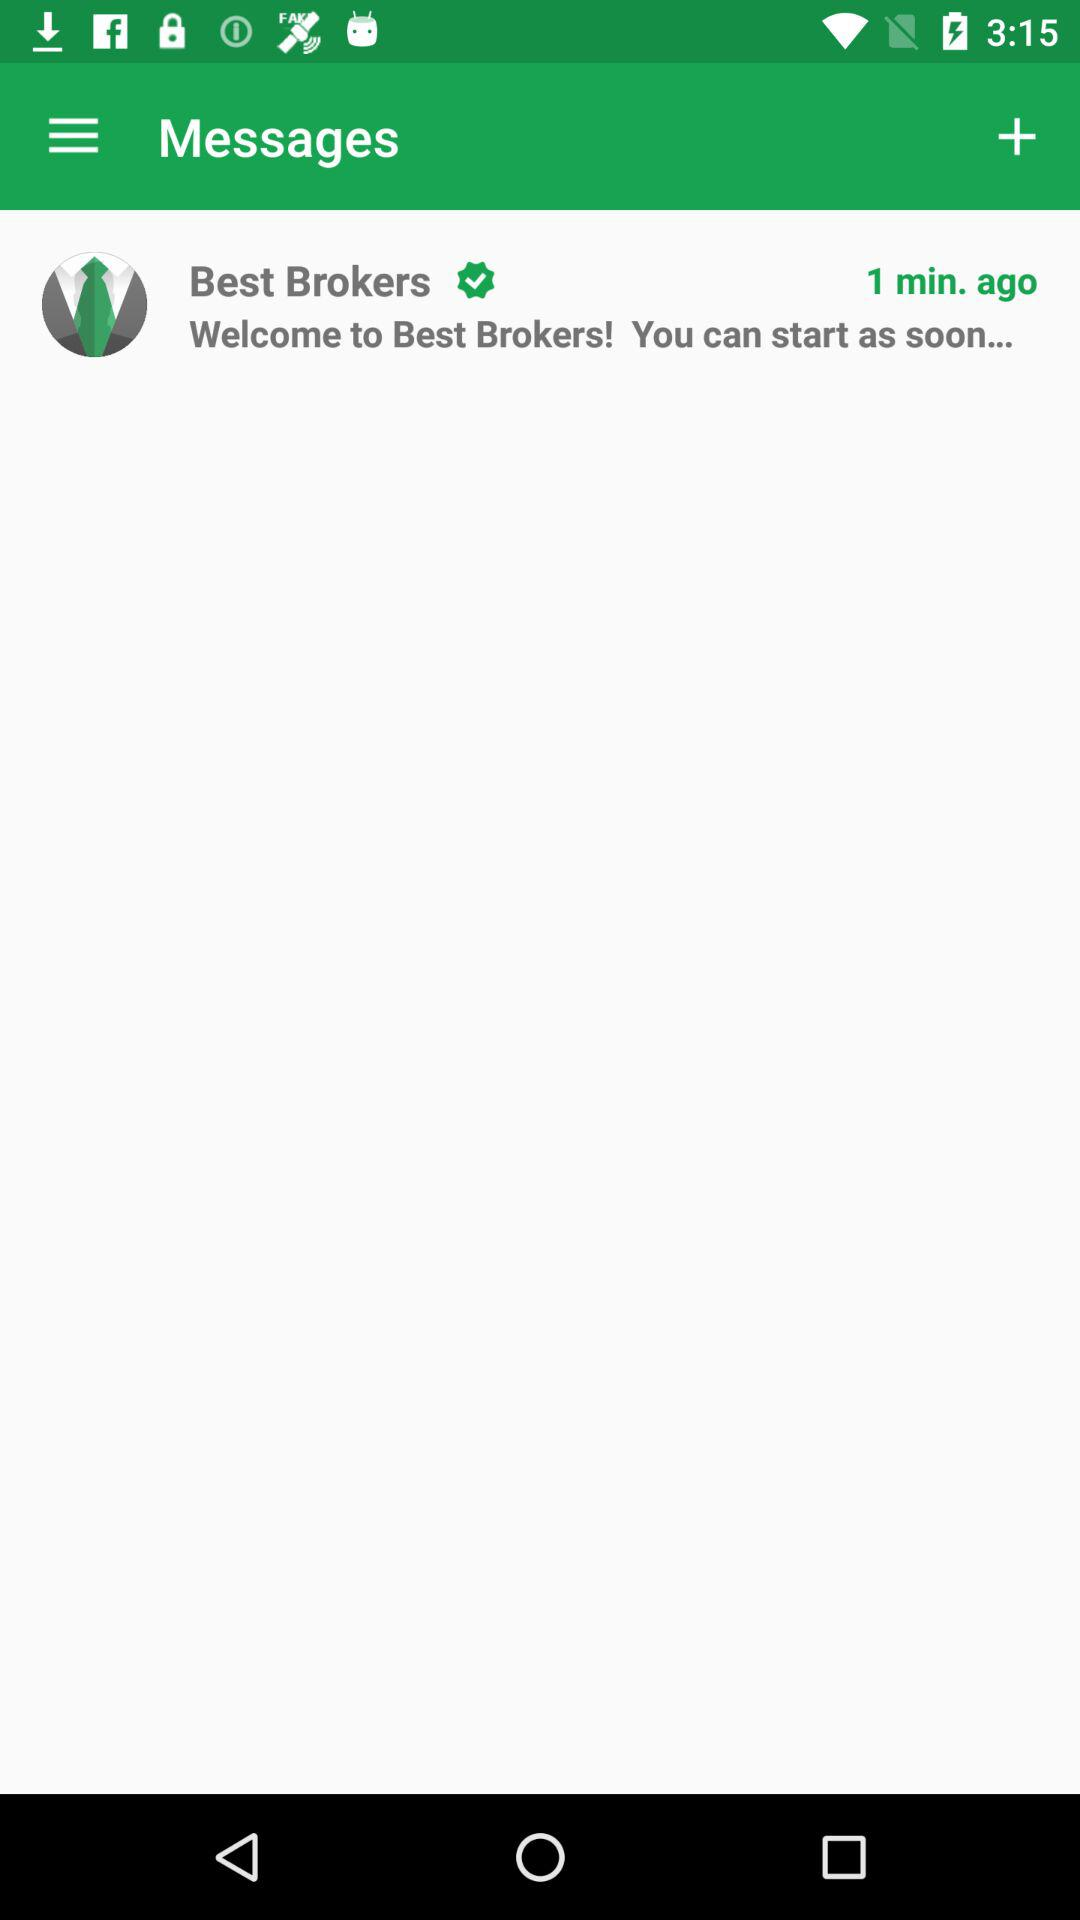How many minutes ago was the message sent?
Answer the question using a single word or phrase. 1 